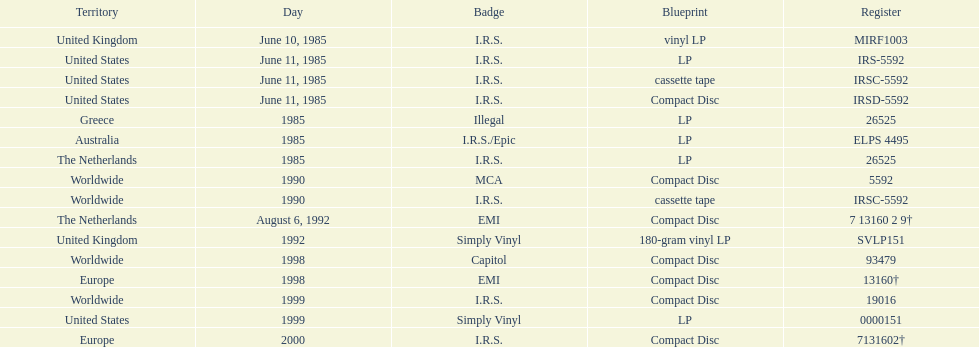What was the date of the first vinyl lp release? June 10, 1985. 